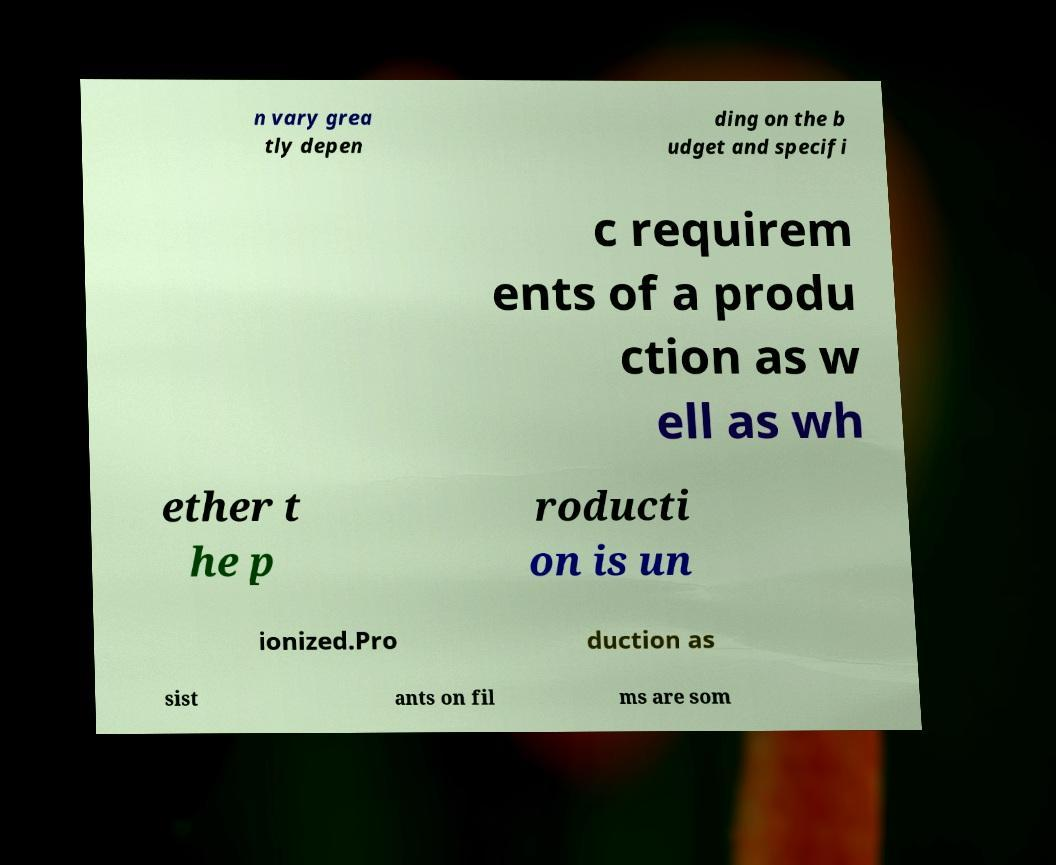There's text embedded in this image that I need extracted. Can you transcribe it verbatim? n vary grea tly depen ding on the b udget and specifi c requirem ents of a produ ction as w ell as wh ether t he p roducti on is un ionized.Pro duction as sist ants on fil ms are som 